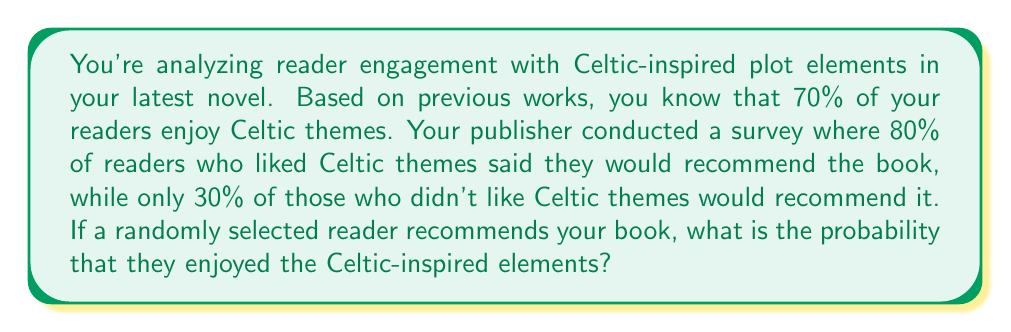Can you answer this question? Let's approach this using Bayes' theorem:

1) Define our events:
   A: Reader enjoys Celtic themes
   B: Reader recommends the book

2) Given probabilities:
   P(A) = 0.7 (prior probability of enjoying Celtic themes)
   P(B|A) = 0.8 (probability of recommending given they enjoy Celtic themes)
   P(B|not A) = 0.3 (probability of recommending given they don't enjoy Celtic themes)

3) We want to find P(A|B) using Bayes' theorem:

   $$P(A|B) = \frac{P(B|A) \cdot P(A)}{P(B)}$$

4) Calculate P(B) using the law of total probability:
   
   $$P(B) = P(B|A) \cdot P(A) + P(B|not A) \cdot P(not A)$$
   $$P(B) = 0.8 \cdot 0.7 + 0.3 \cdot 0.3 = 0.56 + 0.09 = 0.65$$

5) Now we can apply Bayes' theorem:

   $$P(A|B) = \frac{0.8 \cdot 0.7}{0.65} = \frac{0.56}{0.65} \approx 0.8615$$

6) Convert to a percentage: 0.8615 * 100% ≈ 86.15%

Therefore, if a randomly selected reader recommends the book, there's approximately an 86.15% chance they enjoyed the Celtic-inspired elements.
Answer: 86.15% 